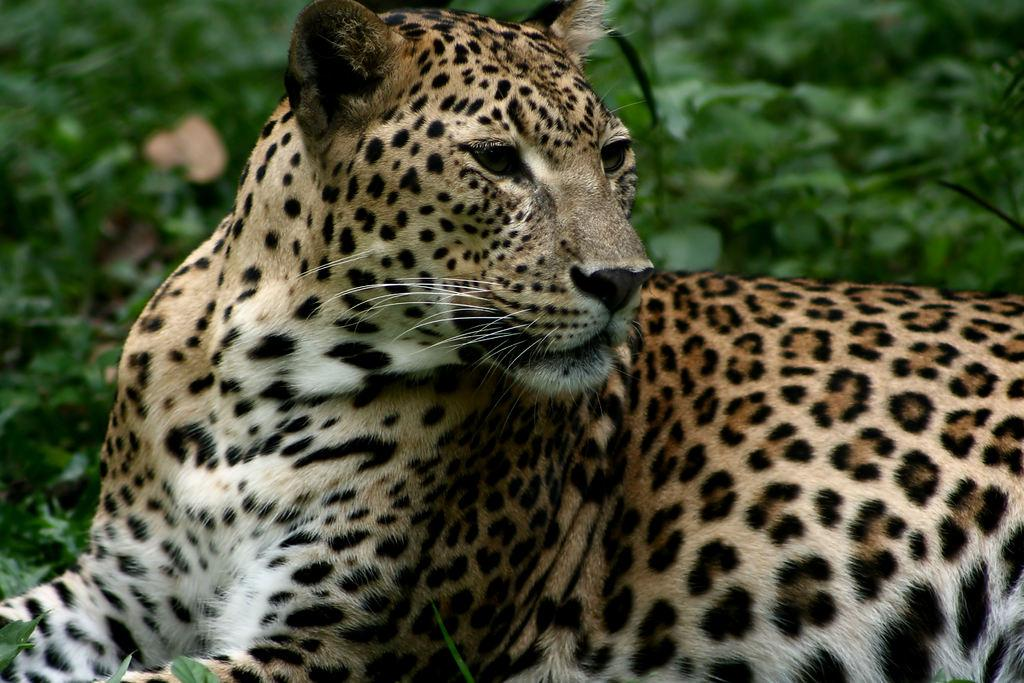What animal is the main subject of the image? There is a leopard in the image. What is the leopard doing in the image? The leopard is sitting. What can be seen in the background of the image? There are plants in the background of the image. What reason does the leopard give for sitting on the ground in the image? The image does not provide any information about the leopard's reason for sitting, and leopards cannot give reasons or speak. 